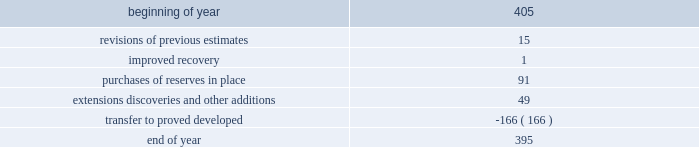For the estimates of our oil sands mining reserves has 33 years of experience in petroleum engineering and has conducted surface mineable oil sands evaluations since 1986 .
He is a member of spe , having served as regional director from 1998 through 2001 and is a registered practicing professional engineer in the province of alberta .
Audits of estimates third-party consultants are engaged to provide independent estimates for fields that comprise 80 percent of our total proved reserves over a rolling four-year period for the purpose of auditing the in-house reserve estimates .
We met this goal for the four-year period ended december 31 , 2011 .
We established a tolerance level of 10 percent such that initial estimates by the third-party consultants are accepted if they are within 10 percent of our internal estimates .
Should the third-party consultants 2019 initial analysis fail to reach our tolerance level , both our team and the consultants re-examine the information provided , request additional data and refine their analysis if appropriate .
This resolution process is continued until both estimates are within 10 percent .
This process did not result in significant changes to our reserve estimates in 2011 or 2009 .
There were no third-party audits performed in 2010 .
During 2011 , netherland , sewell & associates , inc .
( 201cnsai 201d ) prepared a certification of december 31 , 2010 reserves for the alba field in equatorial guinea .
The nsai summary report is filed as an exhibit to this annual report on form 10-k .
The senior members of the nsai team have over 50 years of industry experience between them , having worked for large , international oil and gas companies before joining nsai .
The team lead has a master of science in mechanical engineering and is a member of spe .
The senior technical advisor has a bachelor of science degree in geophysics and is a member of the society of exploration geophysicists , the american association of petroleum geologists and the european association of geoscientists and engineers .
Both are licensed in the state of texas .
Ryder scott company ( 201cryder scott 201d ) performed audits of several of our fields in 2011 and 2009 .
Their summary report on audits performed in 2011 is filed as an exhibit to this annual report on form 10-k .
The team lead for ryder scott has over 20 years of industry experience , having worked for a major international oil and gas company before joining ryder scott .
He has a bachelor of science degree in mechanical engineering , is a member of spe and is a registered professional engineer in the state of texas .
The corporate reserves group also performs separate , detailed technical reviews of reserve estimates for significant fields that were acquired recently or for properties with other indicators such as excessively short or long lives , performance above or below expectations or changes in economic or operating conditions .
Changes in proved undeveloped reserves as of december 31 , 2011 , 395 mmboe of proved undeveloped reserves were reported , a decrease of 10 mmboe from december 31 , 2010 .
The table shows changes in total proved undeveloped reserves for 2011: .
Significant additions to proved undeveloped reserves during 2011 include 91 mmboe due to acreage acquisition in the eagle ford shale , 26 mmboe related to anadarko woodford shale development , 10 mmboe for development drilling in the bakken shale play and 8 mmboe for additional drilling in norway .
Additionally , 139 mmboe were transferred from proved undeveloped to proved developed reserves due to startup of the jackpine upgrader expansion in canada .
Costs incurred in 2011 , 2010 and 2009 relating to the development of proved undeveloped reserves , were $ 1107 million , $ 1463 million and $ 792 million .
Projects can remain in proved undeveloped reserves for extended periods in certain situations such as behind-pipe zones where reserves will not be accessed until the primary producing zone depletes , large development projects which take more than five years to complete , and the timing of when additional gas compression is needed .
Of the 395 mmboe of proved undeveloped reserves at year end 2011 , 34 percent of the volume is associated with projects that have been included in proved reserves for more than five years .
The majority of this volume is related to a compression project in equatorial guinea that was sanctioned by our board of directors in 2004 and is expected to be completed by 2016 .
Performance of this field has exceeded expectations , and estimates of initial dry gas in place increased by roughly 10 percent between 2004 and 2010 .
Production is not expected to experience a natural decline from facility-limited plateau production until 2014 , or possibly 2015 .
The timing of the installation of compression is being driven by the reservoir performance. .
What was the total in mmboe of reserves due to revisions of previous estimates and improved recovery? 
Computations: (15 + 1)
Answer: 16.0. 